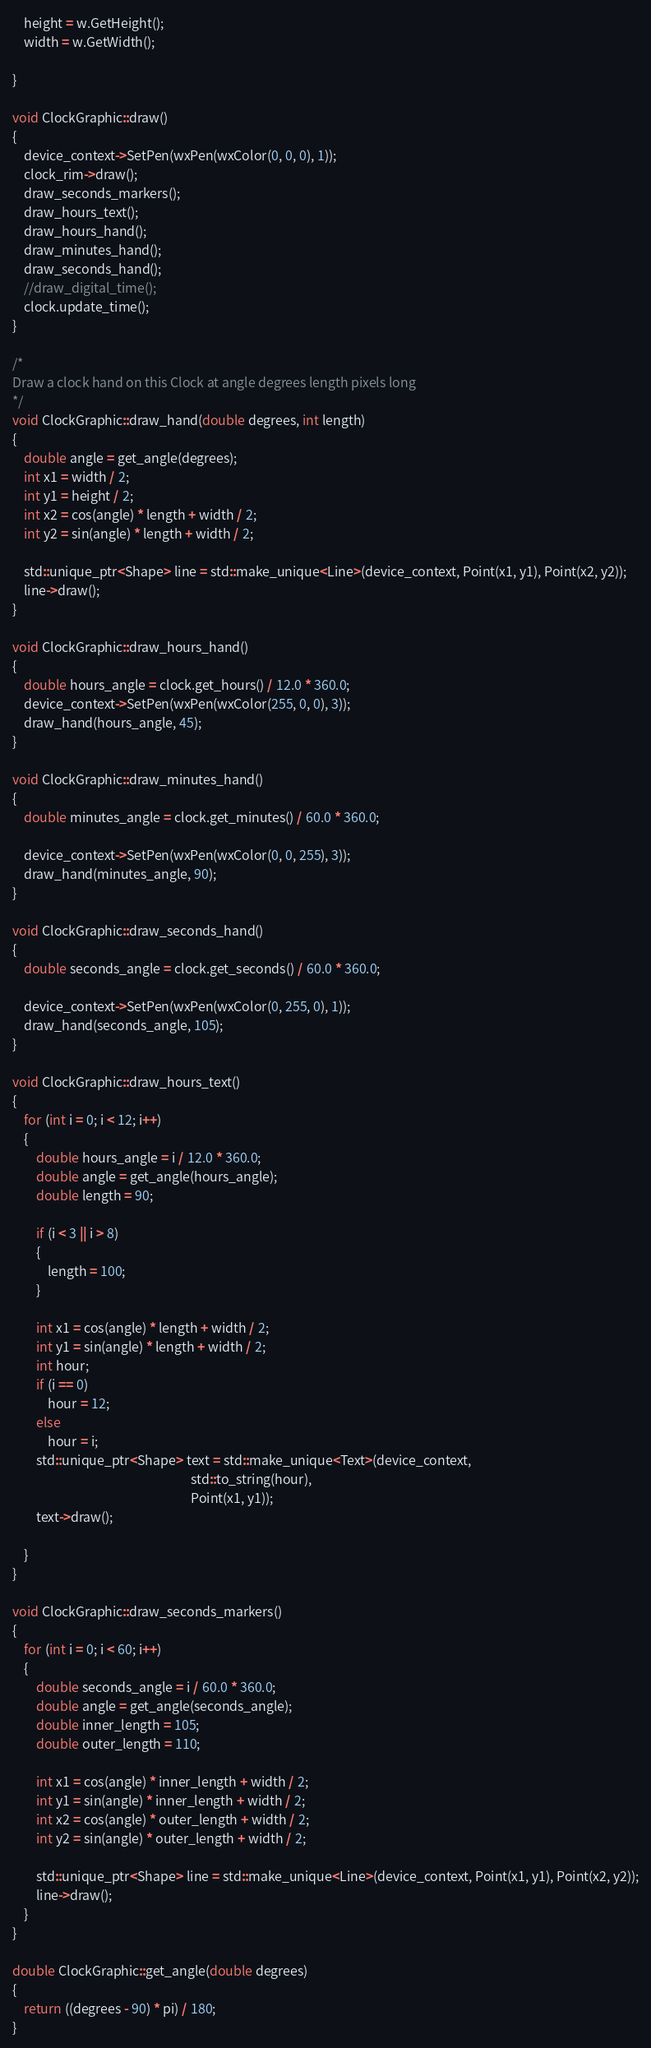<code> <loc_0><loc_0><loc_500><loc_500><_C++_>	height = w.GetHeight();
	width = w.GetWidth();
	
}

void ClockGraphic::draw() 
{
	device_context->SetPen(wxPen(wxColor(0, 0, 0), 1));
	clock_rim->draw();
	draw_seconds_markers();
	draw_hours_text();
	draw_hours_hand();
	draw_minutes_hand();
	draw_seconds_hand();
	//draw_digital_time();
	clock.update_time();
}

/*
Draw a clock hand on this Clock at angle degrees length pixels long
*/
void ClockGraphic::draw_hand(double degrees, int length)
{
	double angle = get_angle(degrees);
	int x1 = width / 2;
	int y1 = height / 2;
	int x2 = cos(angle) * length + width / 2;
	int y2 = sin(angle) * length + width / 2;

	std::unique_ptr<Shape> line = std::make_unique<Line>(device_context, Point(x1, y1), Point(x2, y2));
	line->draw();
}

void ClockGraphic::draw_hours_hand()
{
	double hours_angle = clock.get_hours() / 12.0 * 360.0;
	device_context->SetPen(wxPen(wxColor(255, 0, 0), 3));
	draw_hand(hours_angle, 45);
}

void ClockGraphic::draw_minutes_hand()
{
	double minutes_angle = clock.get_minutes() / 60.0 * 360.0;

	device_context->SetPen(wxPen(wxColor(0, 0, 255), 3));
	draw_hand(minutes_angle, 90);
}

void ClockGraphic::draw_seconds_hand()
{
	double seconds_angle = clock.get_seconds() / 60.0 * 360.0;

	device_context->SetPen(wxPen(wxColor(0, 255, 0), 1));
	draw_hand(seconds_angle, 105);
}

void ClockGraphic::draw_hours_text()
{
	for (int i = 0; i < 12; i++)
	{
		double hours_angle = i / 12.0 * 360.0;
		double angle = get_angle(hours_angle);
		double length = 90;

		if (i < 3 || i > 8) 
		{
			length = 100;
		}

		int x1 = cos(angle) * length + width / 2;
		int y1 = sin(angle) * length + width / 2;
		int hour;
		if (i == 0)
			hour = 12;
		else 
			hour = i;
		std::unique_ptr<Shape> text = std::make_unique<Text>(device_context, 
			                                                 std::to_string(hour),  
															 Point(x1, y1));
		text->draw();

	}
}

void ClockGraphic::draw_seconds_markers()
{
	for (int i = 0; i < 60; i++)
	{
		double seconds_angle = i / 60.0 * 360.0;
		double angle = get_angle(seconds_angle);
		double inner_length = 105;
		double outer_length = 110;

		int x1 = cos(angle) * inner_length + width / 2;
		int y1 = sin(angle) * inner_length + width / 2;
		int x2 = cos(angle) * outer_length + width / 2;
		int y2 = sin(angle) * outer_length + width / 2;
	
		std::unique_ptr<Shape> line = std::make_unique<Line>(device_context, Point(x1, y1), Point(x2, y2));
		line->draw();
	}
}

double ClockGraphic::get_angle(double degrees)
{
	return ((degrees - 90) * pi) / 180;
}

</code> 